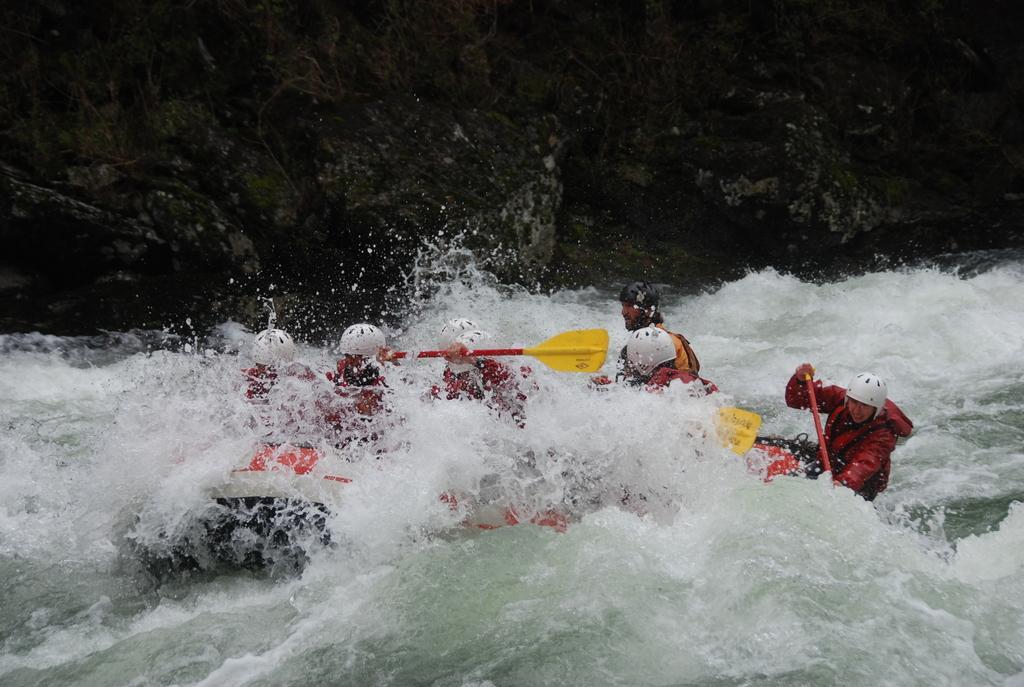Describe this image in one or two sentences. In this image at the bottom there is a river in that river there is one boat, and in the boat there are some persons sitting and riding. And in the background there are some rocks. 